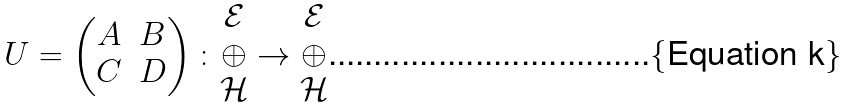Convert formula to latex. <formula><loc_0><loc_0><loc_500><loc_500>U = \begin{pmatrix} A & B \\ C & D \end{pmatrix} \colon \begin{matrix} \mathcal { E } \\ \oplus \\ \mathcal { H } \end{matrix} \to \begin{matrix} \mathcal { E } \\ \oplus \\ \mathcal { H } \end{matrix}</formula> 